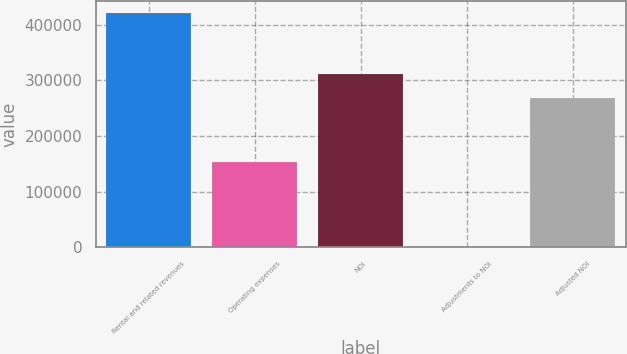<chart> <loc_0><loc_0><loc_500><loc_500><bar_chart><fcel>Rental and related revenues<fcel>Operating expenses<fcel>NOI<fcel>Adjustments to NOI<fcel>Adjusted NOI<nl><fcel>422003<fcel>152875<fcel>310991<fcel>307<fcel>268821<nl></chart> 